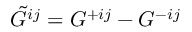Convert formula to latex. <formula><loc_0><loc_0><loc_500><loc_500>\tilde { G } ^ { i j } = G ^ { + i j } - G ^ { - i j }</formula> 